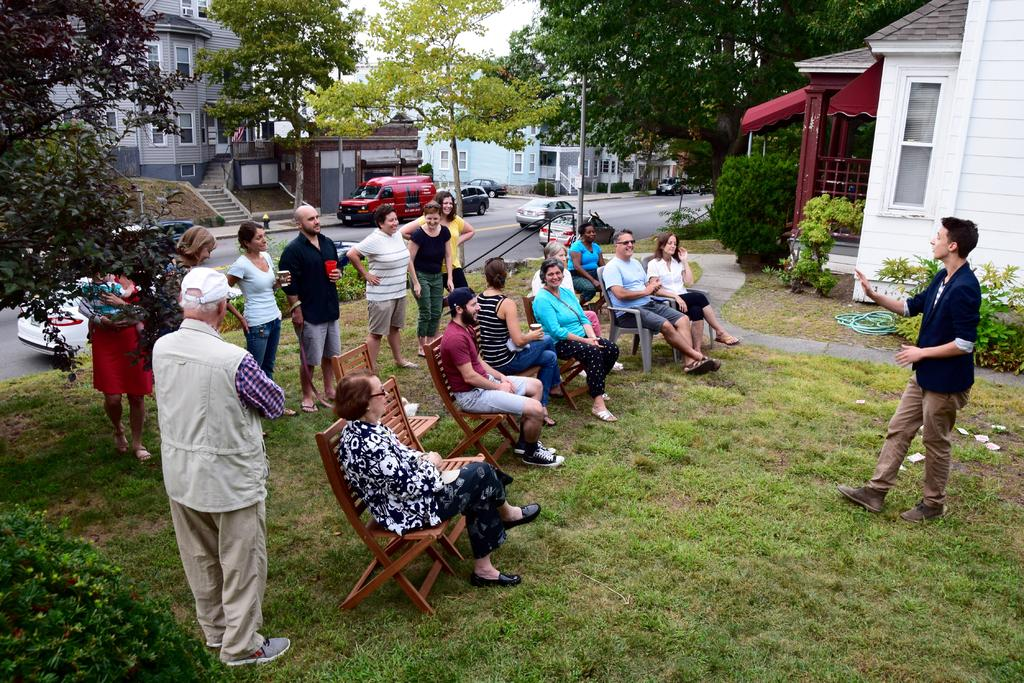What are the people in the image doing? There are people sitting on chairs and standing on the grass in the image. What can be seen in the background of the image? There are houses, cars, and trees in the background of the image. How many vests are being worn by the people in the image? There is no information about vests being worn by the people in the image, so we cannot determine the amount. 